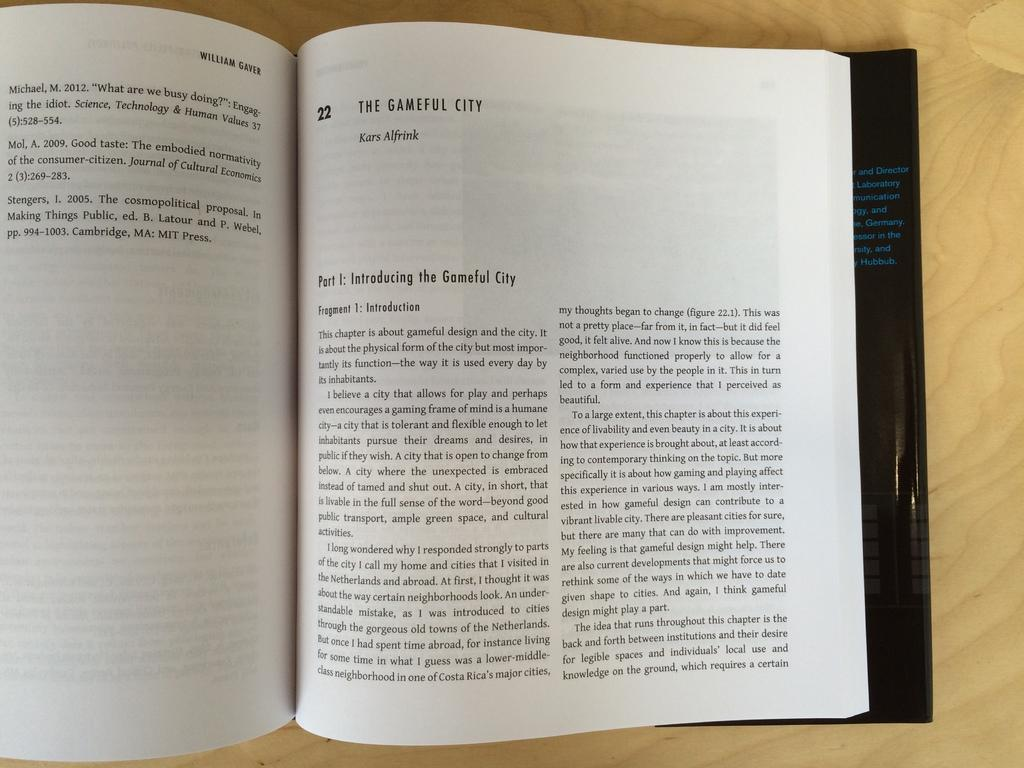<image>
Share a concise interpretation of the image provided. Chapter 22 of a book is called The Gameful City. 